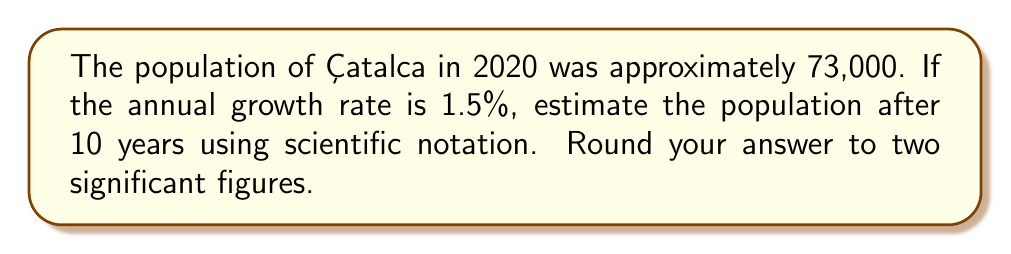Could you help me with this problem? To solve this problem, we'll follow these steps:

1. Set up the compound growth formula:
   $P = P_0 \cdot (1 + r)^t$
   Where:
   $P$ is the final population
   $P_0$ is the initial population
   $r$ is the annual growth rate
   $t$ is the number of years

2. Plug in the values:
   $P = 73,000 \cdot (1 + 0.015)^{10}$

3. Calculate the result:
   $P = 73,000 \cdot (1.015)^{10}$
   $P = 73,000 \cdot 1.1605$
   $P = 84,716.5$

4. Convert to scientific notation:
   $P = 8.47165 \times 10^4$

5. Round to two significant figures:
   $P = 8.5 \times 10^4$

This result estimates that the population of Çatalca after 10 years will be approximately 85,000 people.
Answer: $8.5 \times 10^4$ 